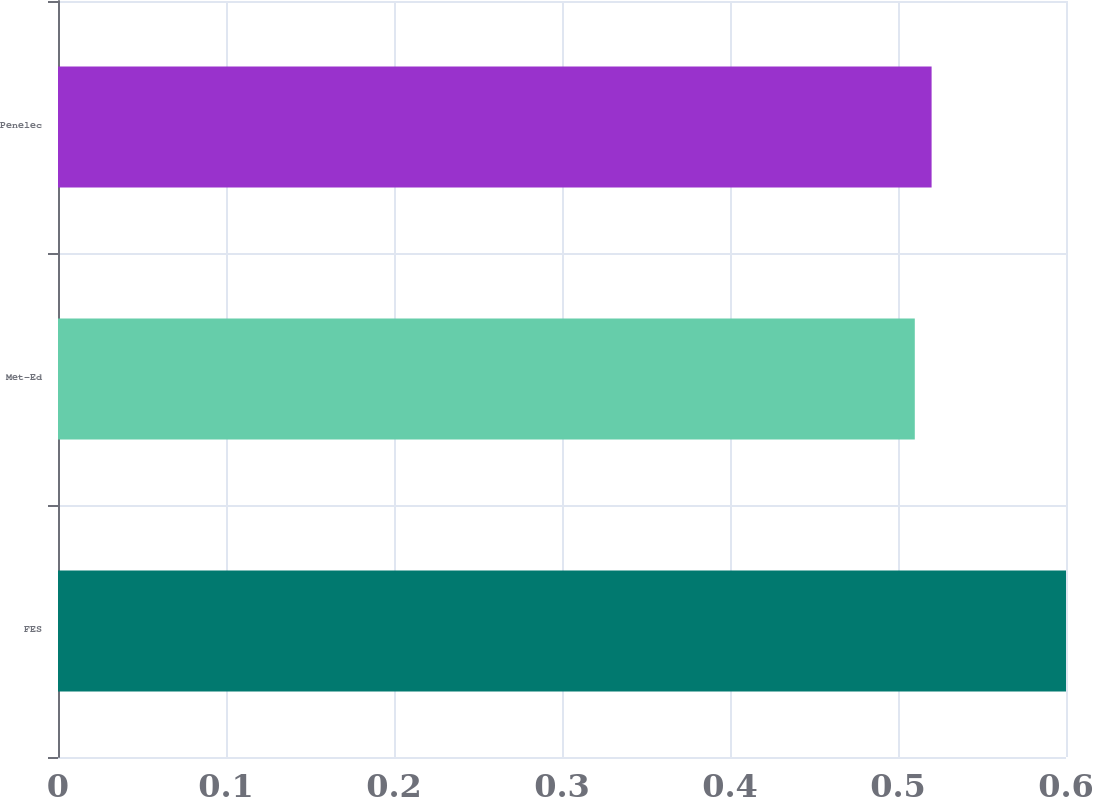Convert chart. <chart><loc_0><loc_0><loc_500><loc_500><bar_chart><fcel>FES<fcel>Met-Ed<fcel>Penelec<nl><fcel>0.6<fcel>0.51<fcel>0.52<nl></chart> 